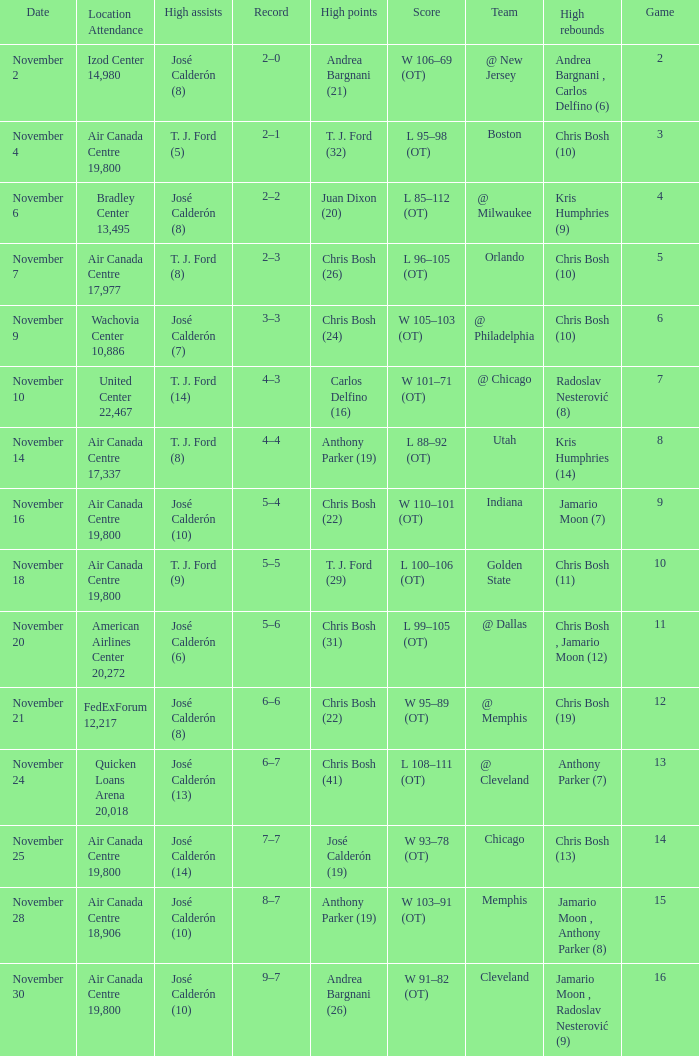Who had the high points when chris bosh (13) had the high rebounds? José Calderón (19). 